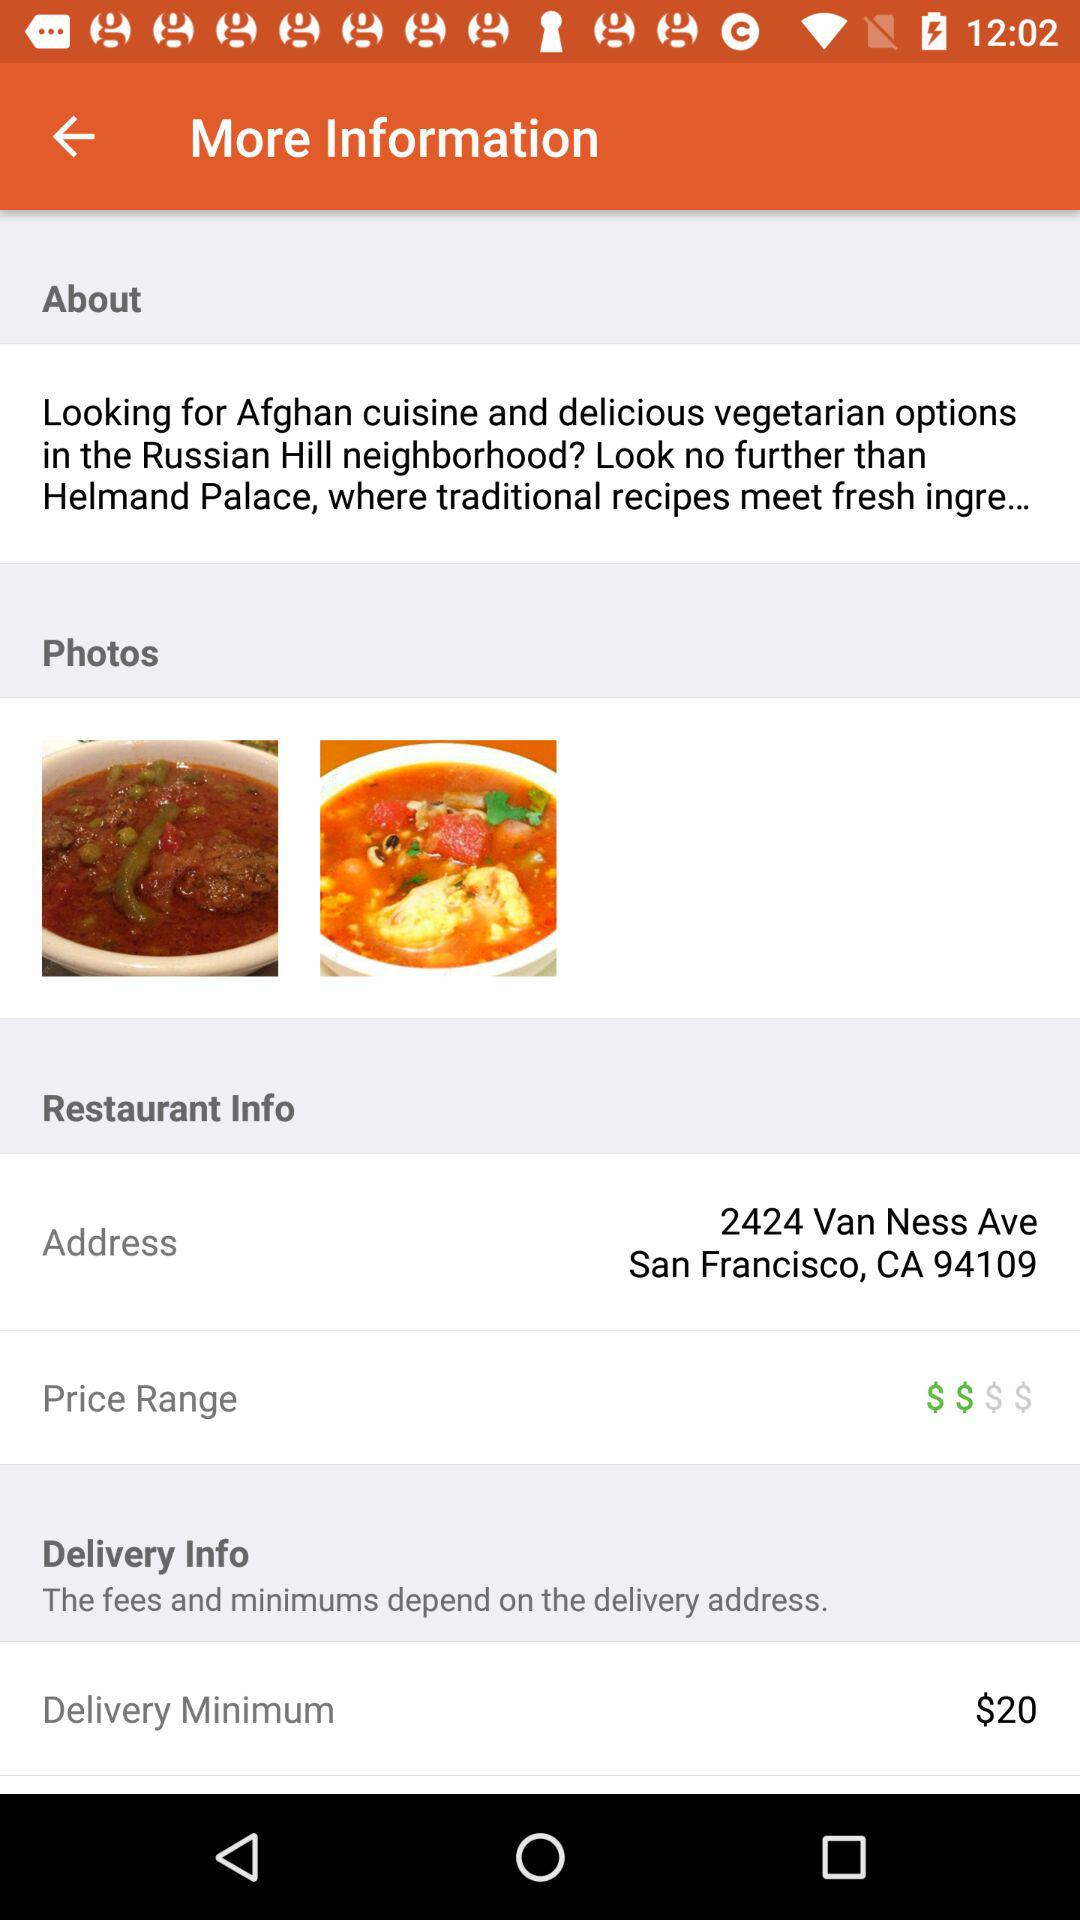What is the minimum delivery amount? The minimum delivery amount is $20. 